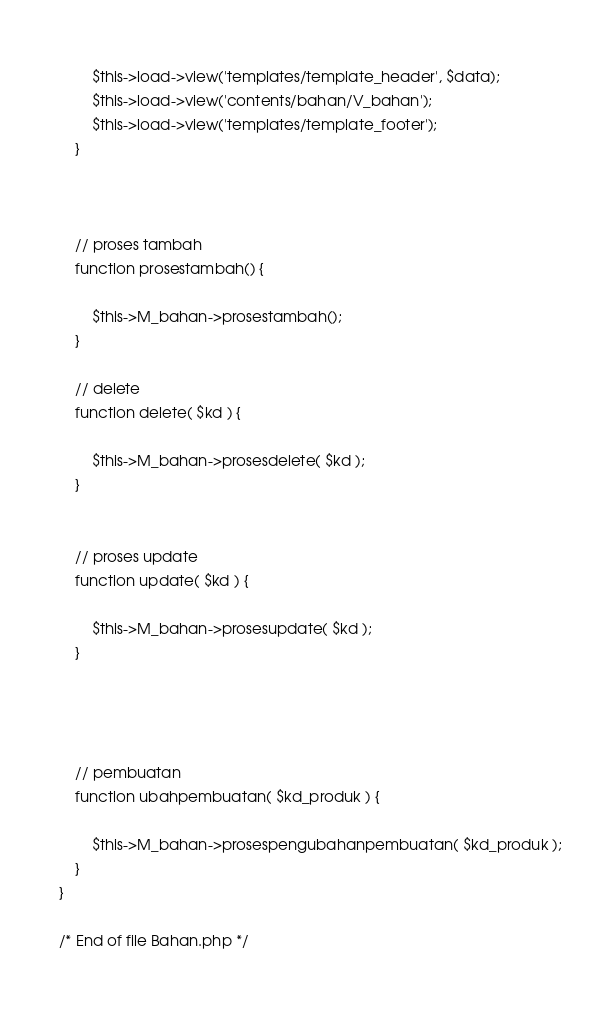Convert code to text. <code><loc_0><loc_0><loc_500><loc_500><_PHP_>            
            $this->load->view('templates/template_header', $data);
            $this->load->view('contents/bahan/V_bahan');
            $this->load->view('templates/template_footer');
        }



        // proses tambah 
        function prosestambah() {

            $this->M_bahan->prosestambah();
        }

        // delete
        function delete( $kd ) {

            $this->M_bahan->prosesdelete( $kd );
        }


        // proses update
        function update( $kd ) {

            $this->M_bahan->prosesupdate( $kd );
        }
        



        // pembuatan
        function ubahpembuatan( $kd_produk ) {

            $this->M_bahan->prosespengubahanpembuatan( $kd_produk );
        }
    }
    
    /* End of file Bahan.php */
    </code> 